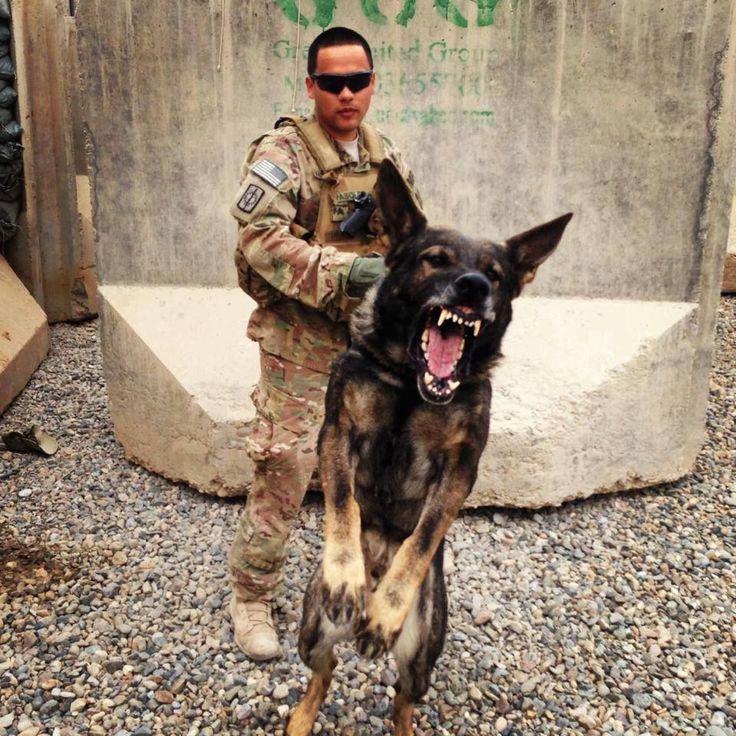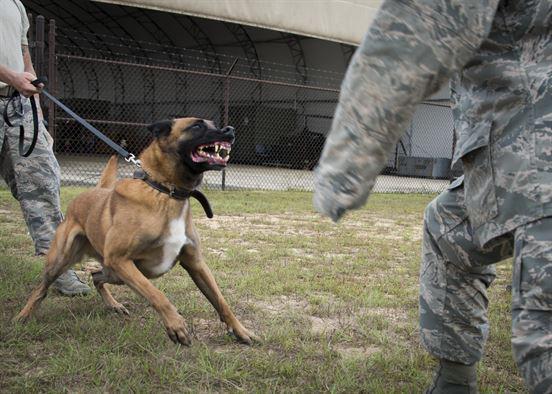The first image is the image on the left, the second image is the image on the right. Assess this claim about the two images: "A person in camo attire interacts with a dog in both images.". Correct or not? Answer yes or no. Yes. 